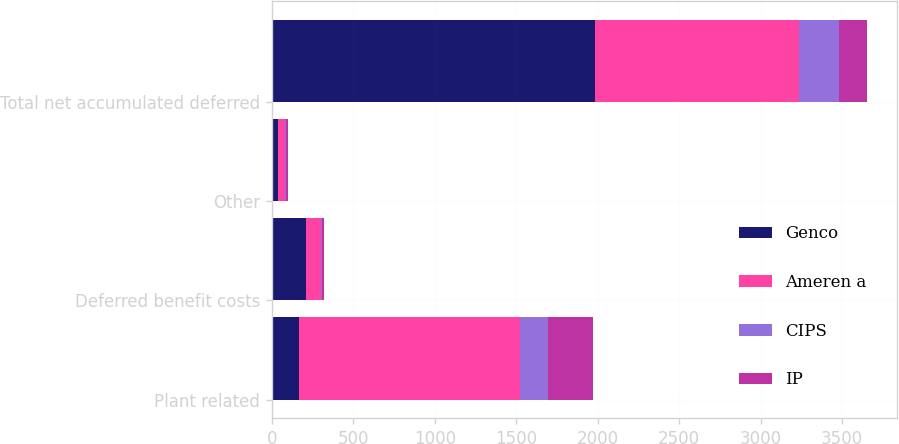<chart> <loc_0><loc_0><loc_500><loc_500><stacked_bar_chart><ecel><fcel>Plant related<fcel>Deferred benefit costs<fcel>Other<fcel>Total net accumulated deferred<nl><fcel>Genco<fcel>168<fcel>209<fcel>39<fcel>1983<nl><fcel>Ameren a<fcel>1355<fcel>91<fcel>39<fcel>1252<nl><fcel>CIPS<fcel>171<fcel>8<fcel>10<fcel>250<nl><fcel>IP<fcel>276<fcel>11<fcel>12<fcel>168<nl></chart> 